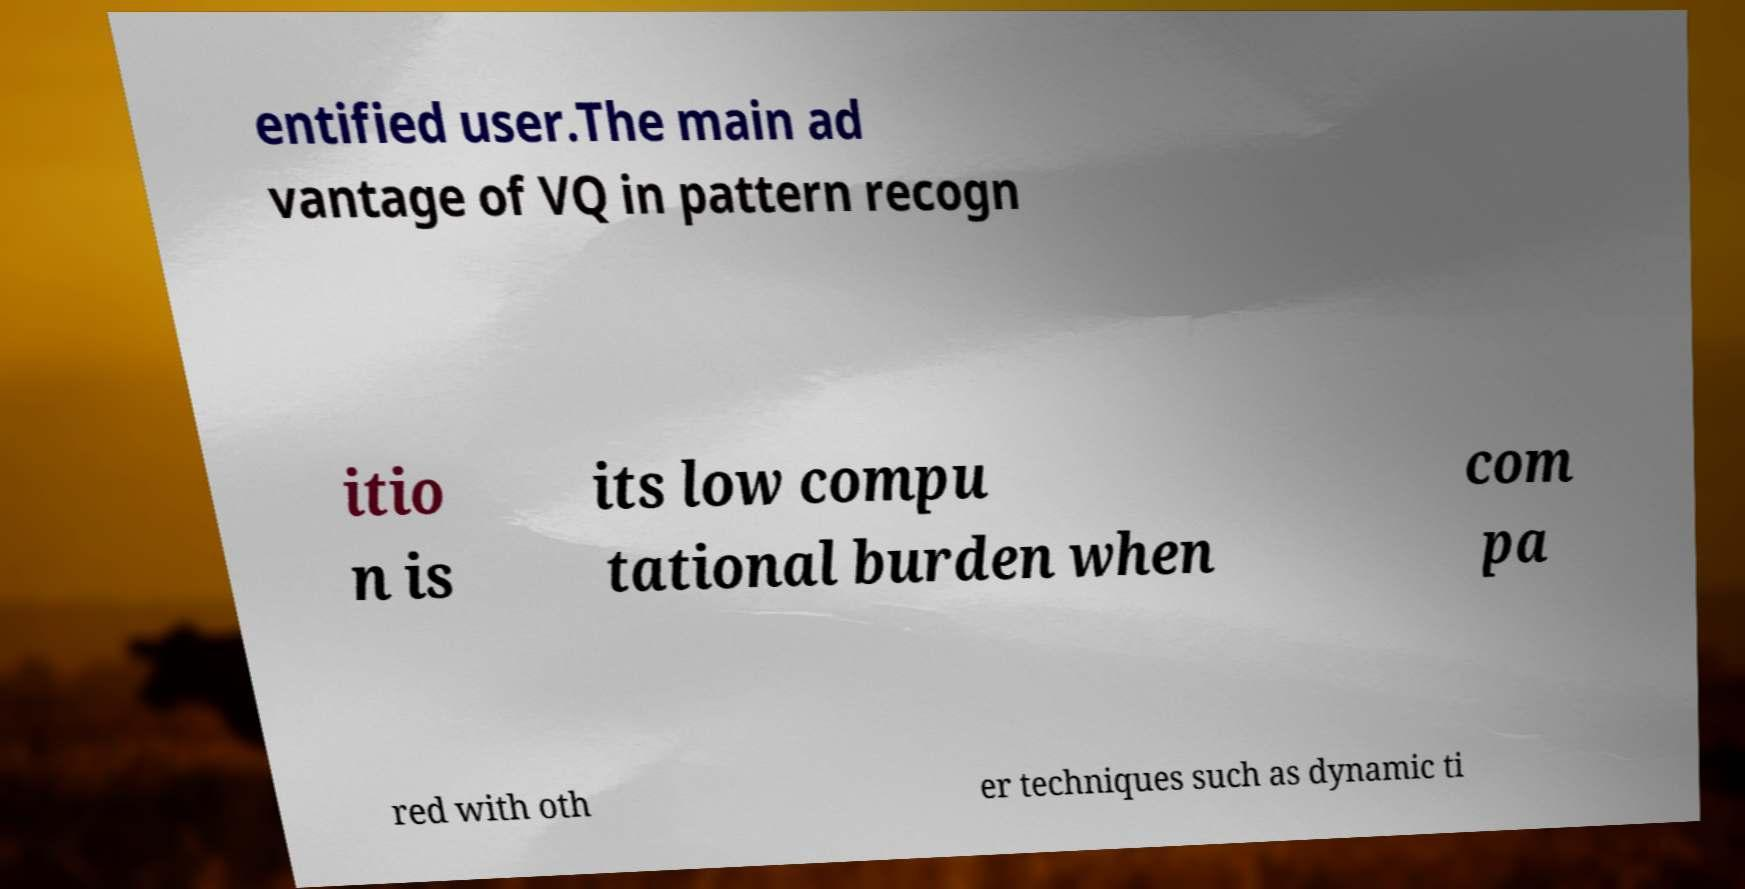For documentation purposes, I need the text within this image transcribed. Could you provide that? entified user.The main ad vantage of VQ in pattern recogn itio n is its low compu tational burden when com pa red with oth er techniques such as dynamic ti 